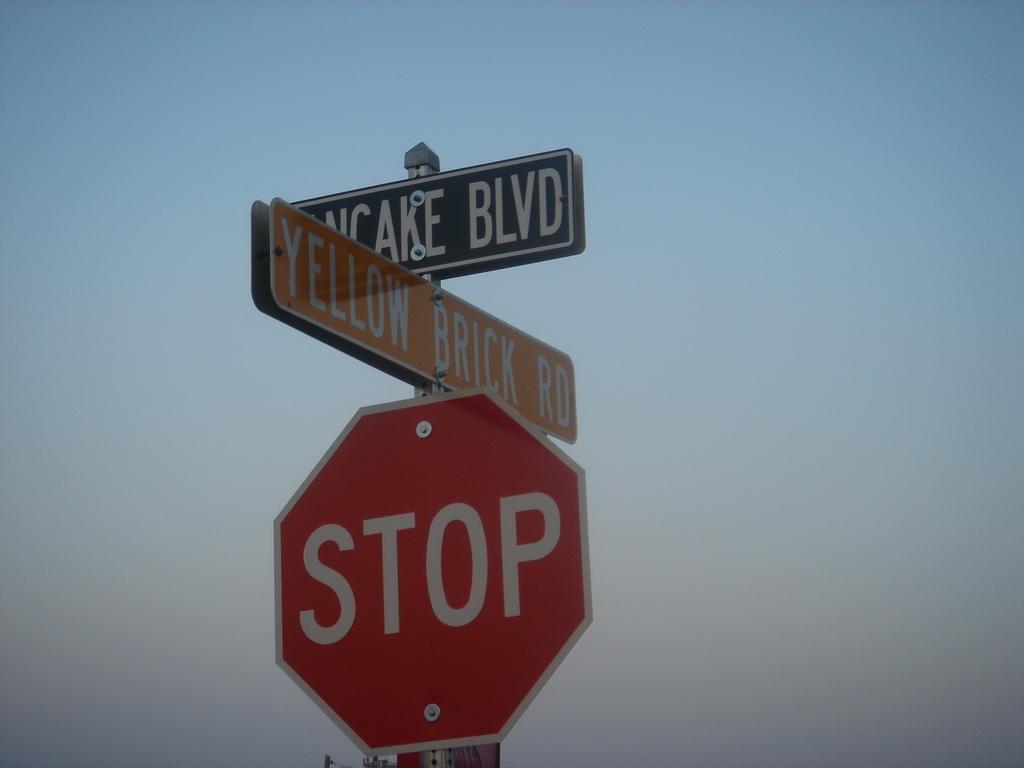What color road is mentioned on the sign?
Offer a very short reply. Yellow. What is the red sign directing drivers to do?
Offer a very short reply. Stop. 